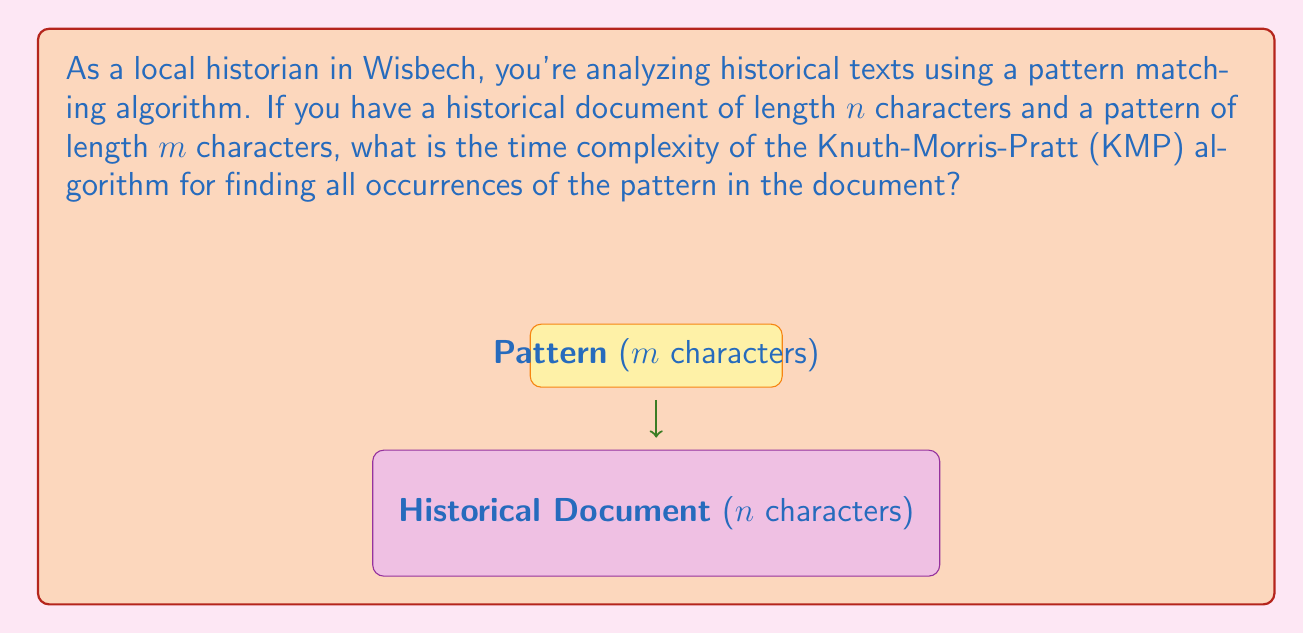Can you solve this math problem? To determine the time complexity of the Knuth-Morris-Pratt (KMP) algorithm, let's break down its steps:

1. Preprocessing phase:
   - The KMP algorithm first preprocesses the pattern to create a failure function.
   - This preprocessing takes $O(m)$ time, where $m$ is the length of the pattern.

2. Matching phase:
   - The algorithm then scans the document once, comparing characters and using the failure function to skip unnecessary comparisons.
   - This phase takes $O(n)$ time, where $n$ is the length of the document.

3. Total time complexity:
   - The total time is the sum of the preprocessing and matching phases.
   - Therefore, the time complexity is $O(m) + O(n) = O(m + n)$.

4. Comparison with naive approach:
   - A naive algorithm would have a worst-case time complexity of $O(mn)$.
   - KMP is more efficient, especially for large documents or repeated searches.

5. Space complexity:
   - The KMP algorithm uses additional space for the failure function, which is $O(m)$.
   - This is generally not included in the time complexity but is worth noting.

In the context of analyzing historical texts in Wisbech, this means the KMP algorithm's efficiency doesn't degrade significantly with longer documents or patterns, making it suitable for processing large volumes of historical text efficiently.
Answer: $O(m + n)$ 